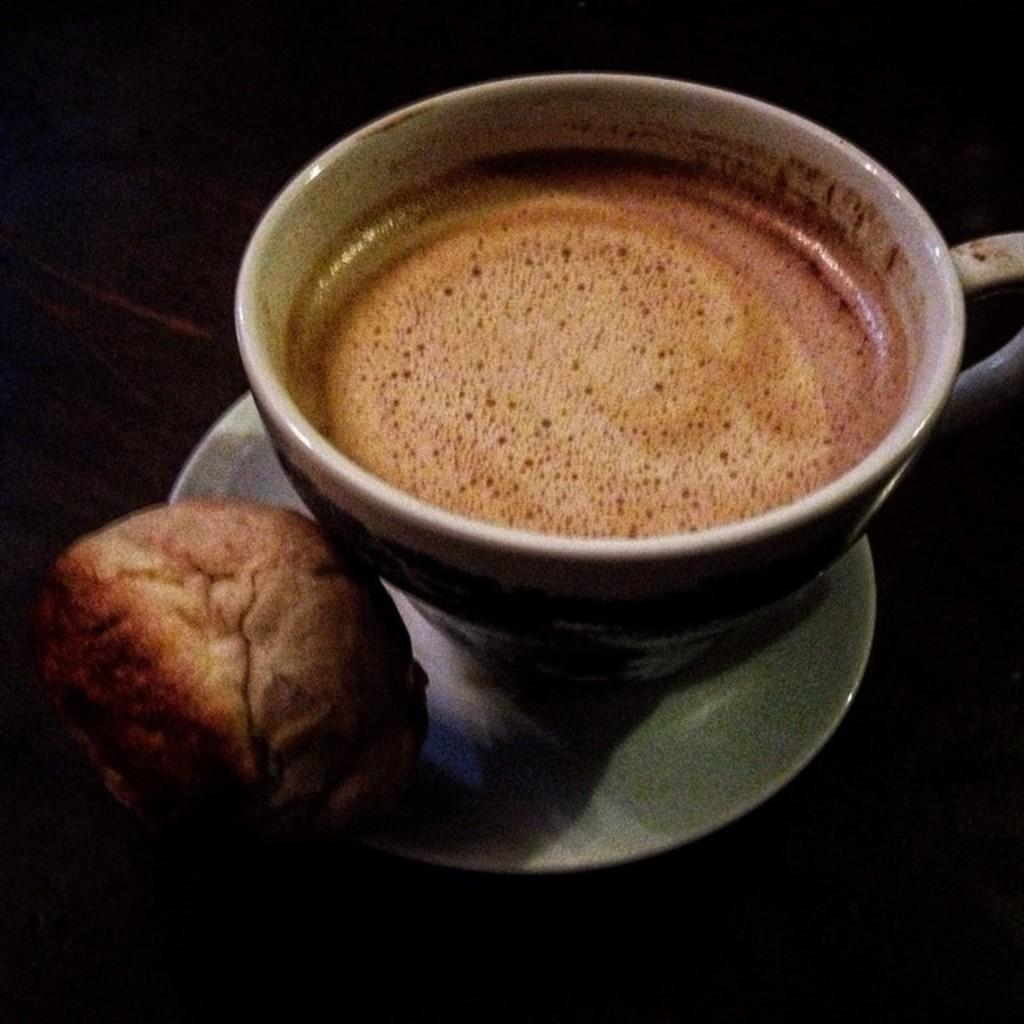What is the main object in the image? There is a coffee cup in the image. What is the coffee cup placed on? The coffee cup is on a saucer. What color is the saucer? The saucer is white. What type of food is visible in the image? There is a bun in the image. On which side of the image is the bun located? The bun is on the left side of the image. Is the person driving the car shown in the image? There is no car or person driving in the image; it only features a coffee cup, saucer, and bun. What type of pin is holding the bun together in the image? There is no pin present in the image; the bun is not held together by any visible means. 